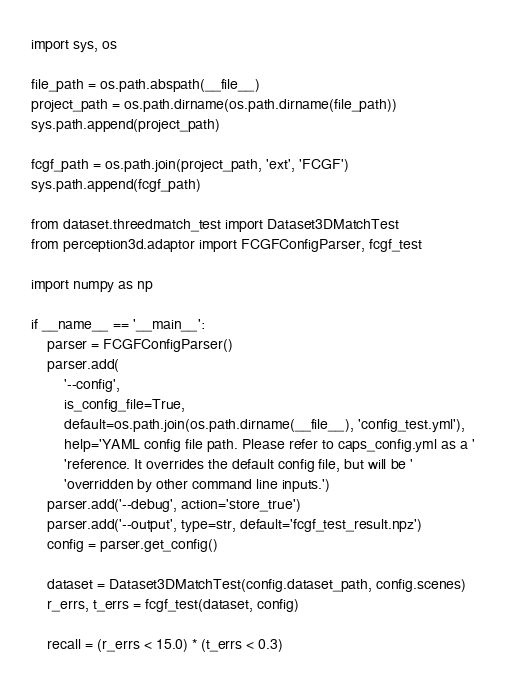Convert code to text. <code><loc_0><loc_0><loc_500><loc_500><_Python_>import sys, os

file_path = os.path.abspath(__file__)
project_path = os.path.dirname(os.path.dirname(file_path))
sys.path.append(project_path)

fcgf_path = os.path.join(project_path, 'ext', 'FCGF')
sys.path.append(fcgf_path)

from dataset.threedmatch_test import Dataset3DMatchTest
from perception3d.adaptor import FCGFConfigParser, fcgf_test

import numpy as np

if __name__ == '__main__':
    parser = FCGFConfigParser()
    parser.add(
        '--config',
        is_config_file=True,
        default=os.path.join(os.path.dirname(__file__), 'config_test.yml'),
        help='YAML config file path. Please refer to caps_config.yml as a '
        'reference. It overrides the default config file, but will be '
        'overridden by other command line inputs.')
    parser.add('--debug', action='store_true')
    parser.add('--output', type=str, default='fcgf_test_result.npz')
    config = parser.get_config()

    dataset = Dataset3DMatchTest(config.dataset_path, config.scenes)
    r_errs, t_errs = fcgf_test(dataset, config)

    recall = (r_errs < 15.0) * (t_errs < 0.3)</code> 